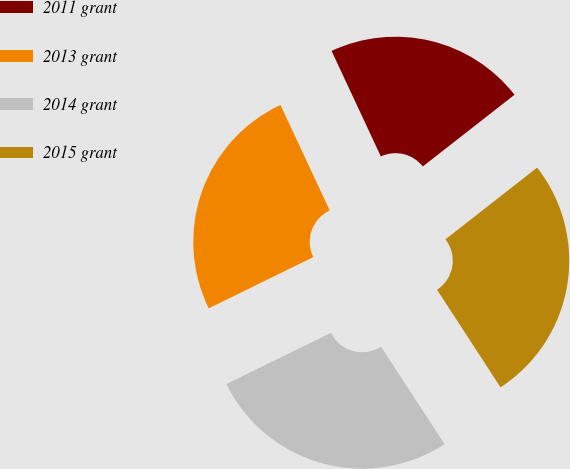Convert chart to OTSL. <chart><loc_0><loc_0><loc_500><loc_500><pie_chart><fcel>2011 grant<fcel>2013 grant<fcel>2014 grant<fcel>2015 grant<nl><fcel>21.39%<fcel>25.3%<fcel>26.93%<fcel>26.38%<nl></chart> 